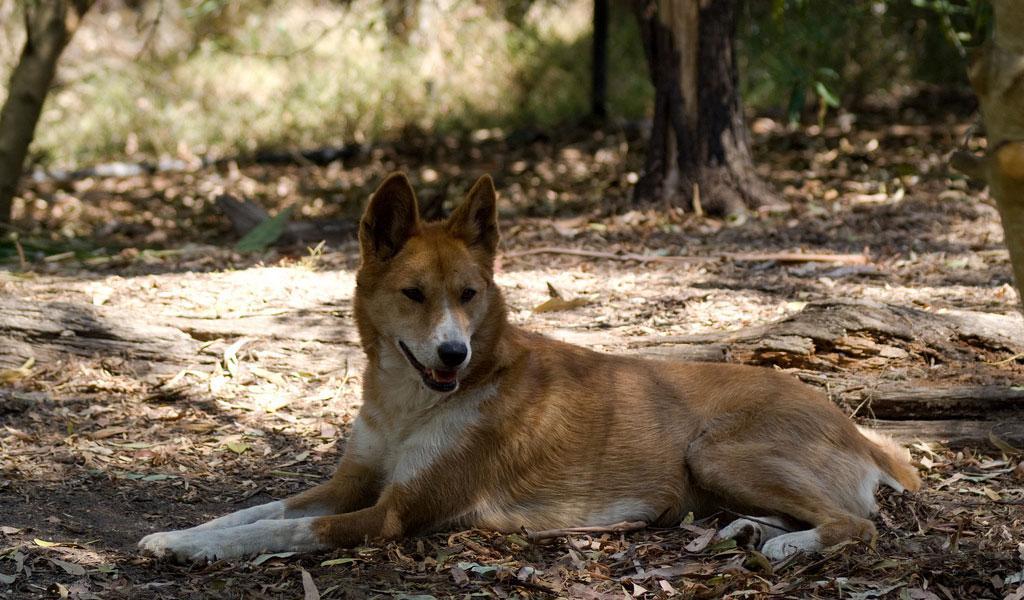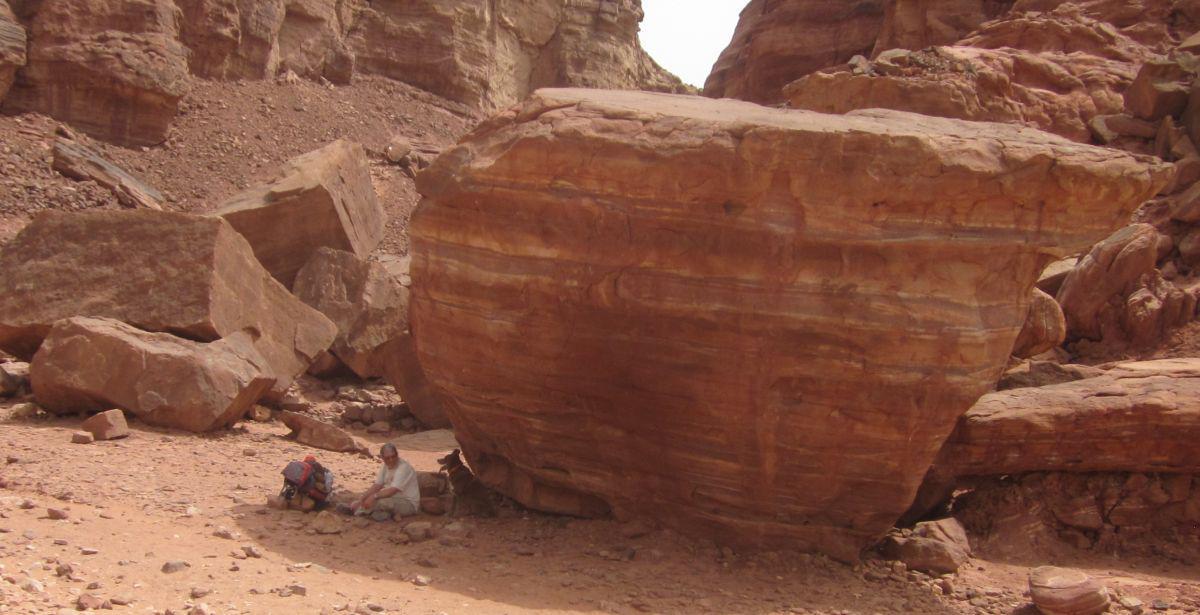The first image is the image on the left, the second image is the image on the right. Considering the images on both sides, is "there is a canine lying down in the image to the left" valid? Answer yes or no. Yes. The first image is the image on the left, the second image is the image on the right. For the images shown, is this caption "The left image features a dingo reclining with upright head, and all dingos shown are adults." true? Answer yes or no. Yes. 